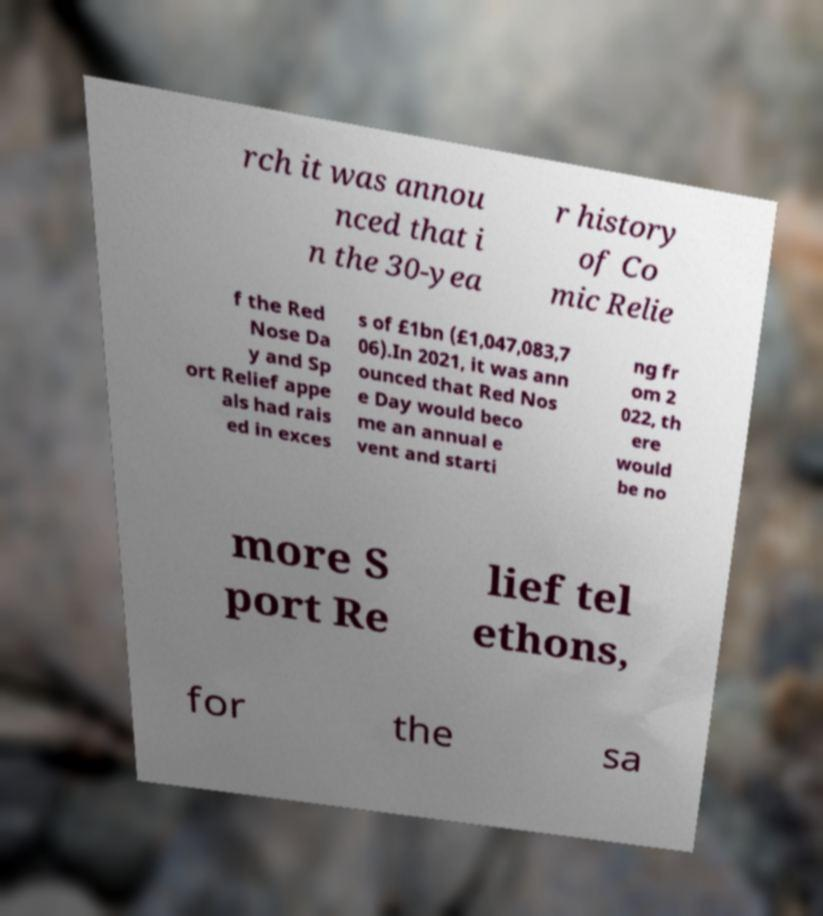There's text embedded in this image that I need extracted. Can you transcribe it verbatim? rch it was annou nced that i n the 30-yea r history of Co mic Relie f the Red Nose Da y and Sp ort Relief appe als had rais ed in exces s of £1bn (£1,047,083,7 06).In 2021, it was ann ounced that Red Nos e Day would beco me an annual e vent and starti ng fr om 2 022, th ere would be no more S port Re lief tel ethons, for the sa 